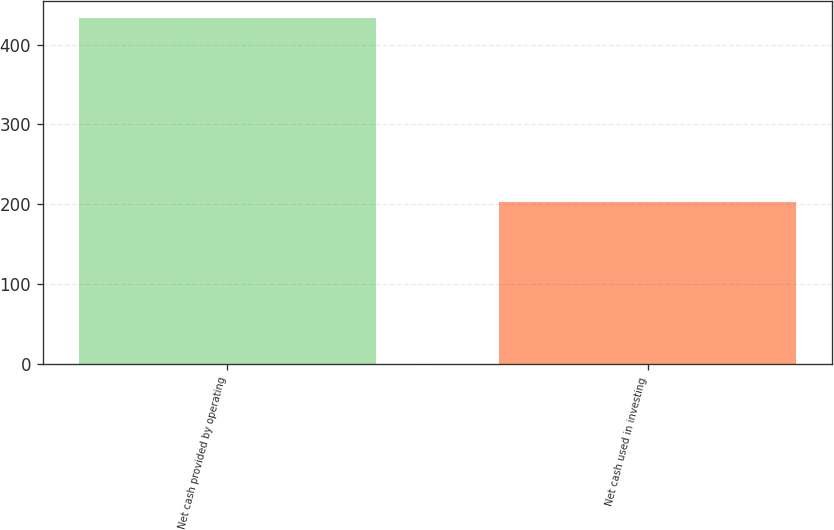Convert chart to OTSL. <chart><loc_0><loc_0><loc_500><loc_500><bar_chart><fcel>Net cash provided by operating<fcel>Net cash used in investing<nl><fcel>432.9<fcel>202.5<nl></chart> 